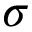<formula> <loc_0><loc_0><loc_500><loc_500>\sigma</formula> 